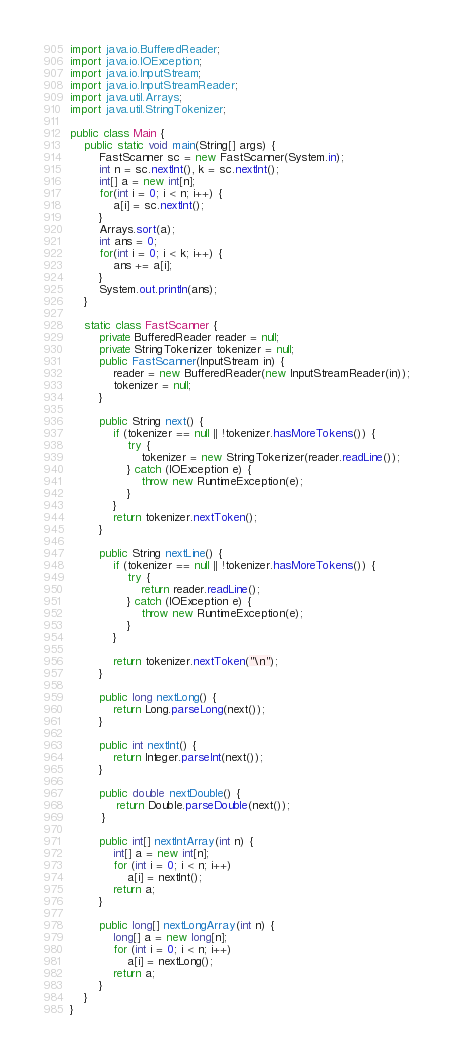<code> <loc_0><loc_0><loc_500><loc_500><_Java_>import java.io.BufferedReader;
import java.io.IOException;
import java.io.InputStream;
import java.io.InputStreamReader;
import java.util.Arrays;
import java.util.StringTokenizer;

public class Main {
	public static void main(String[] args) {
		FastScanner sc = new FastScanner(System.in);
		int n = sc.nextInt(), k = sc.nextInt();
		int[] a = new int[n];
		for(int i = 0; i < n; i++) {
			a[i] = sc.nextInt();
		}
		Arrays.sort(a);
		int ans = 0;
		for(int i = 0; i < k; i++) {
			ans += a[i];
		}
		System.out.println(ans);
	}

	static class FastScanner {
		private BufferedReader reader = null;
	    private StringTokenizer tokenizer = null;
	    public FastScanner(InputStream in) {
	        reader = new BufferedReader(new InputStreamReader(in));
	        tokenizer = null;
	    }

	    public String next() {
	        if (tokenizer == null || !tokenizer.hasMoreTokens()) {
	            try {
	                tokenizer = new StringTokenizer(reader.readLine());
	            } catch (IOException e) {
	                throw new RuntimeException(e);
	            }
	        }
	        return tokenizer.nextToken();
	    }

	    public String nextLine() {
	        if (tokenizer == null || !tokenizer.hasMoreTokens()) {
	            try {
	                return reader.readLine();
	            } catch (IOException e) {
	                throw new RuntimeException(e);
	            }
	        }

	        return tokenizer.nextToken("\n");
	    }

	    public long nextLong() {
	        return Long.parseLong(next());
	    }

	    public int nextInt() {
	        return Integer.parseInt(next());
	    }

	    public double nextDouble() {
	         return Double.parseDouble(next());
	     }

	    public int[] nextIntArray(int n) {
	        int[] a = new int[n];
	        for (int i = 0; i < n; i++)
	            a[i] = nextInt();
	        return a;
	    }

	    public long[] nextLongArray(int n) {
	        long[] a = new long[n];
	        for (int i = 0; i < n; i++)
	            a[i] = nextLong();
	        return a;
	    }
	}
}
</code> 